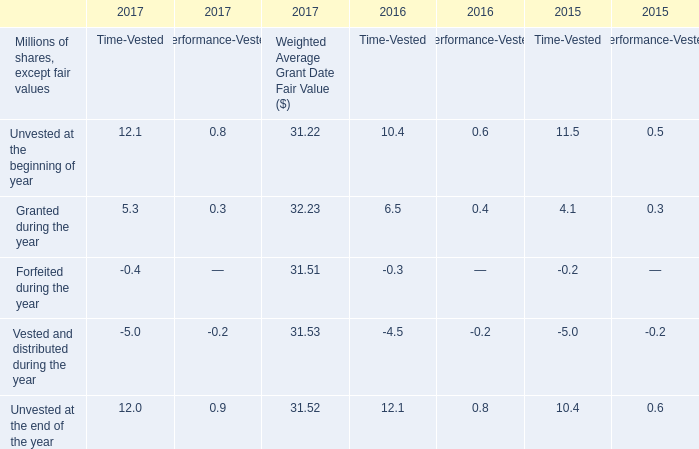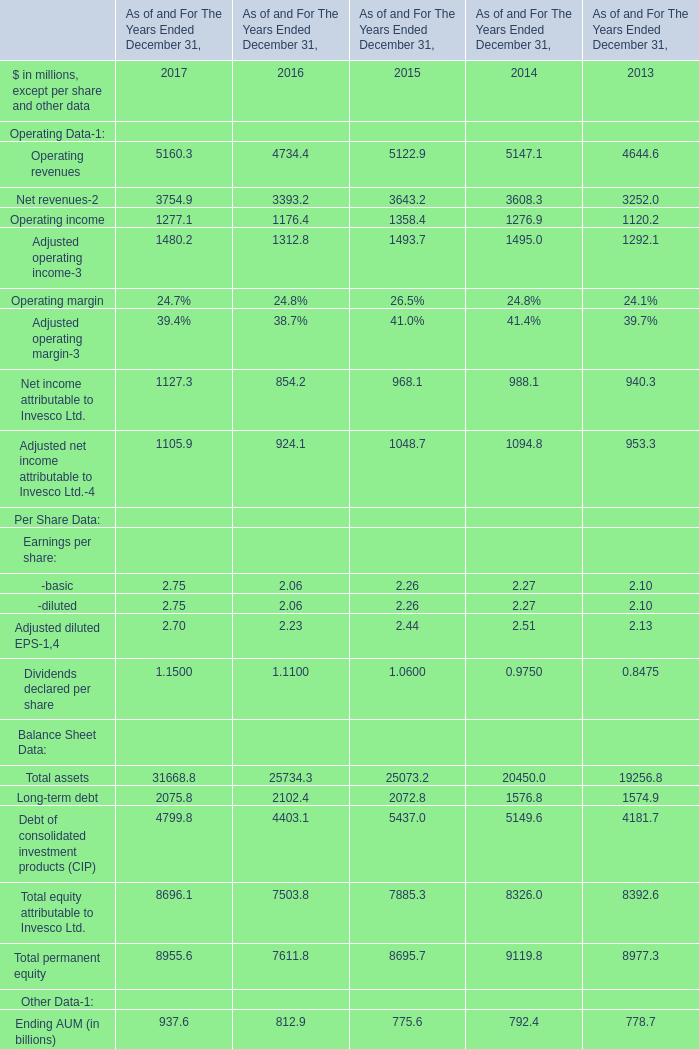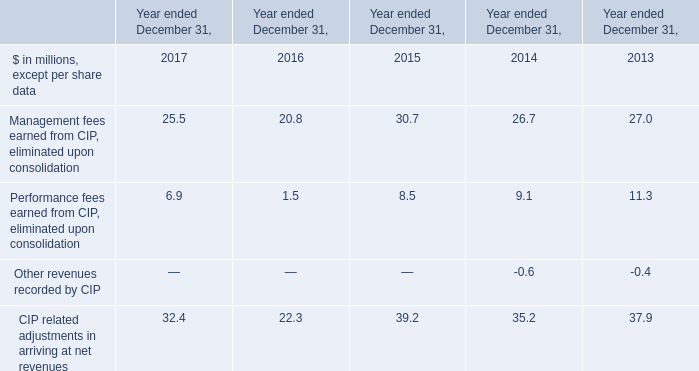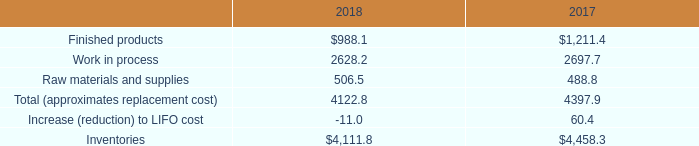what was the percentage change in raw materials and supplies between 2017 and 2018? 
Computations: ((506.5 - 488.8) / 488.8)
Answer: 0.03621. 